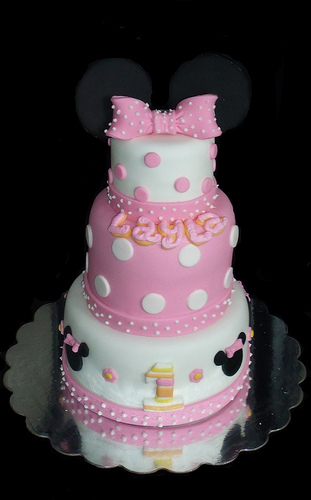<image>
Is the cake to the left of the number? No. The cake is not to the left of the number. From this viewpoint, they have a different horizontal relationship. 